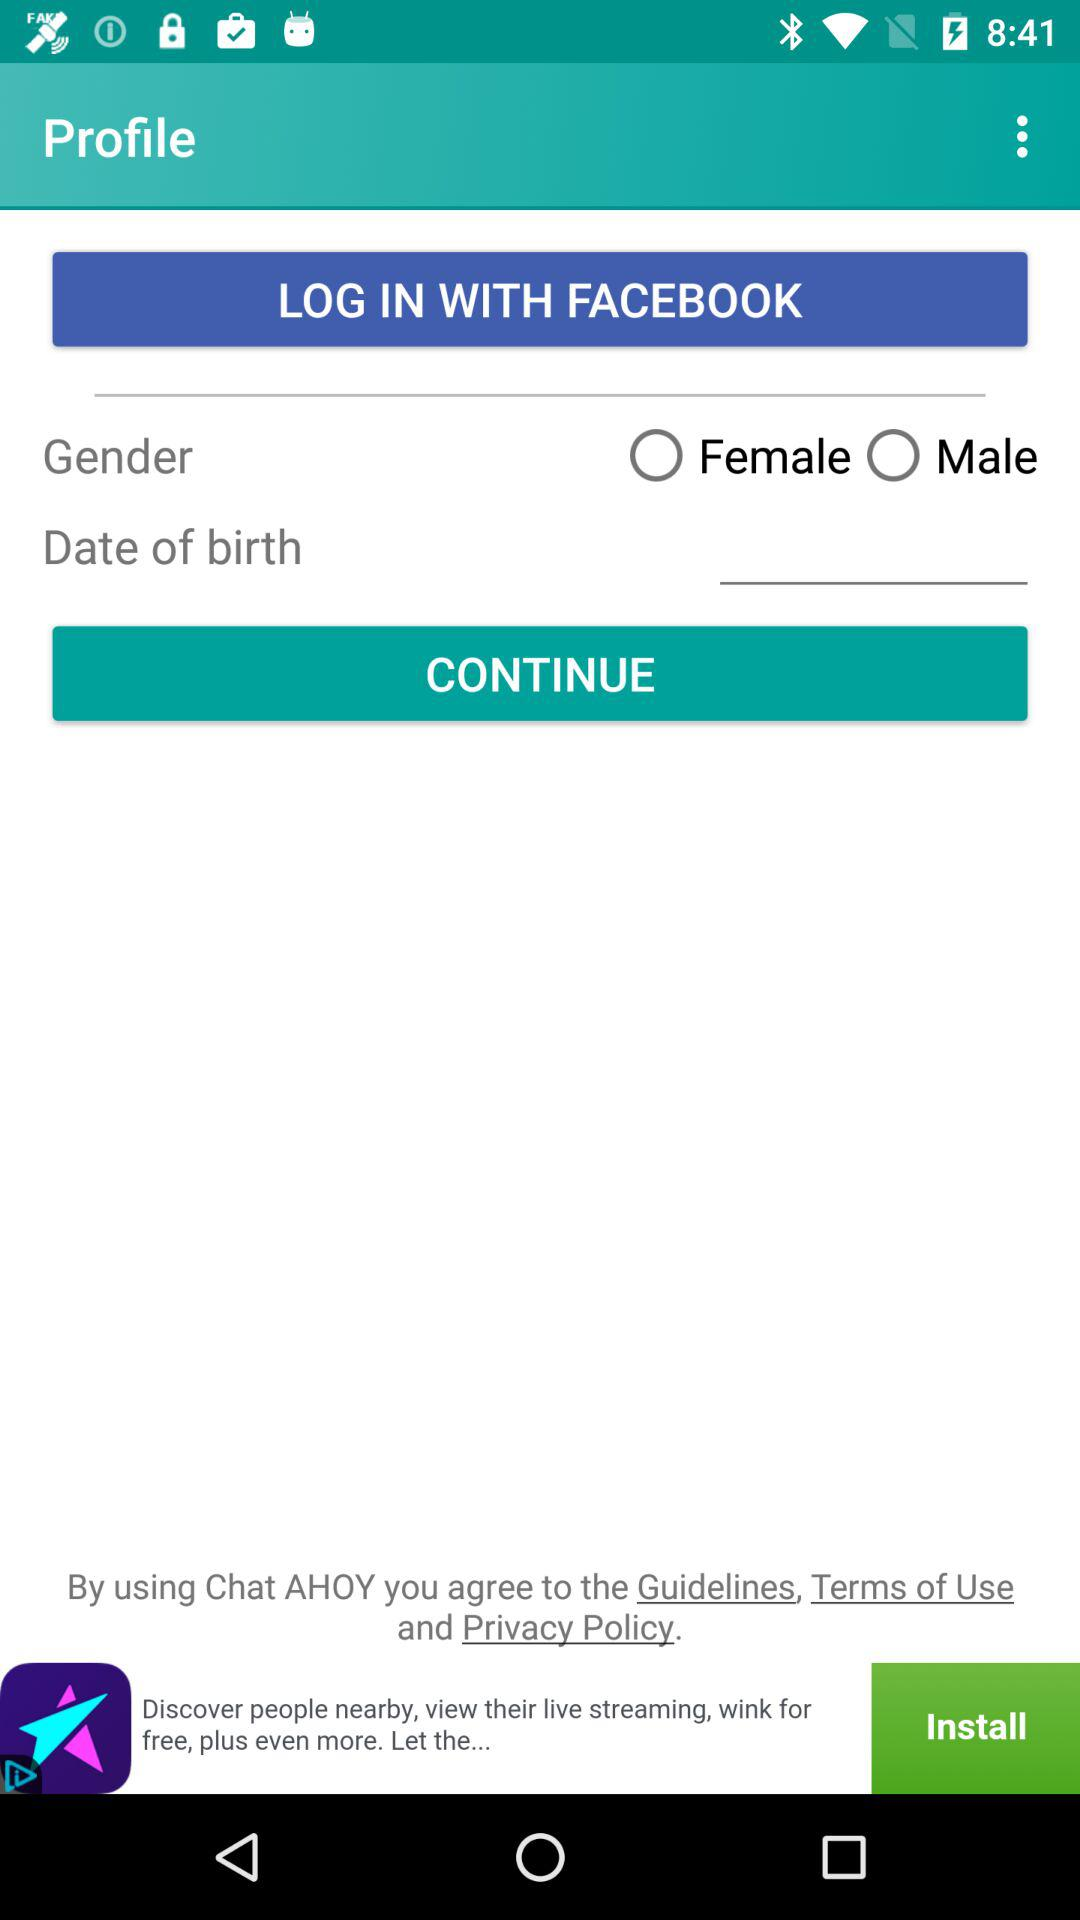From which application we are accessing? The application is "Facebook". 